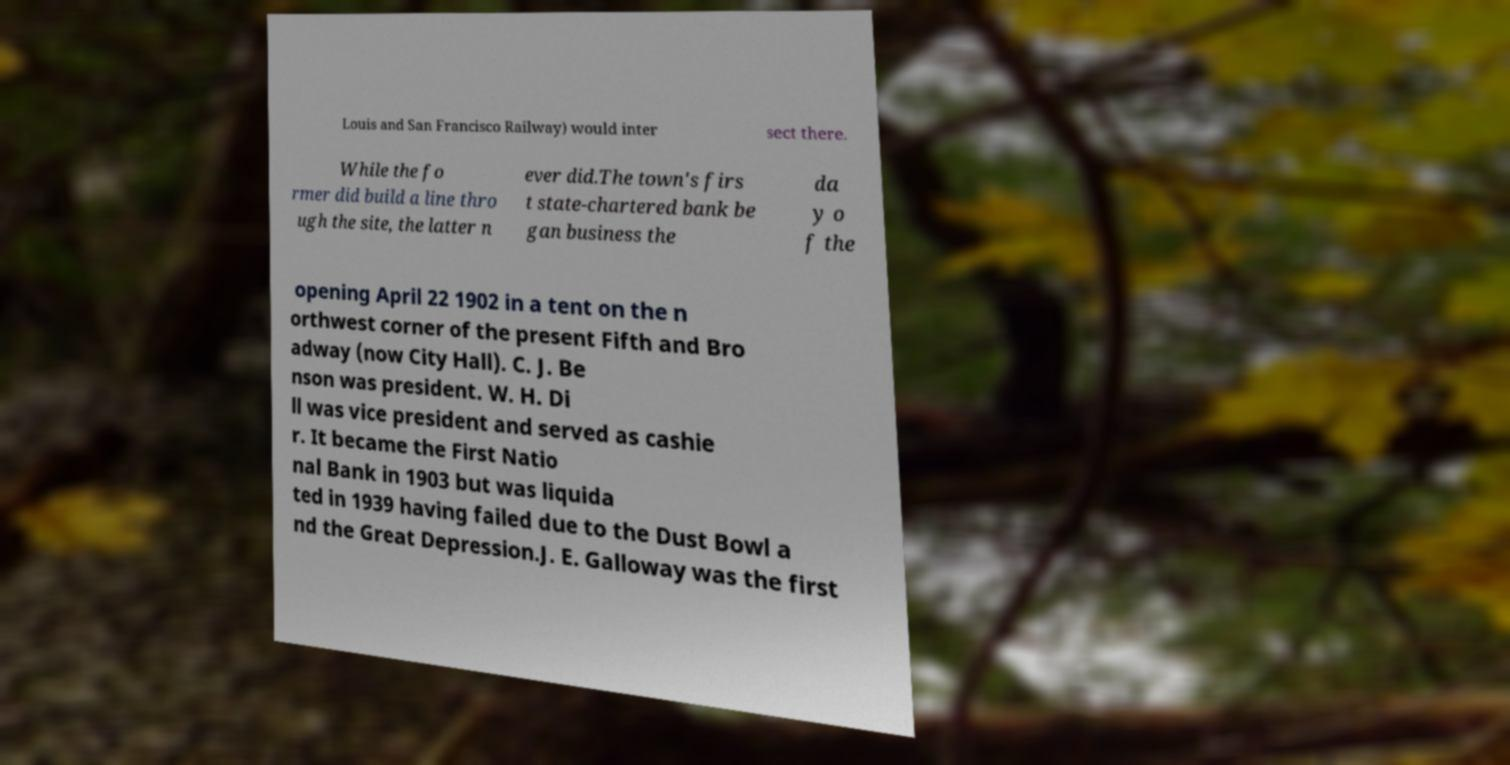For documentation purposes, I need the text within this image transcribed. Could you provide that? Louis and San Francisco Railway) would inter sect there. While the fo rmer did build a line thro ugh the site, the latter n ever did.The town's firs t state-chartered bank be gan business the da y o f the opening April 22 1902 in a tent on the n orthwest corner of the present Fifth and Bro adway (now City Hall). C. J. Be nson was president. W. H. Di ll was vice president and served as cashie r. It became the First Natio nal Bank in 1903 but was liquida ted in 1939 having failed due to the Dust Bowl a nd the Great Depression.J. E. Galloway was the first 